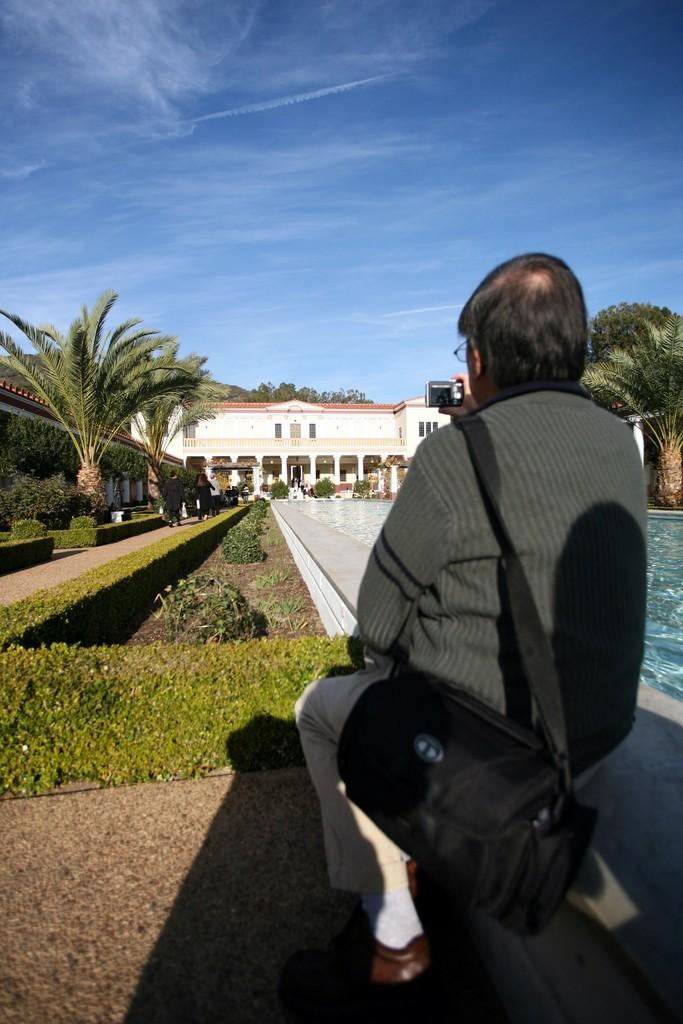What is the person in the image doing? The person is taking a photo. What can be seen behind the person in the image? There are trees, plants, water, a building, and the sky visible behind the person. Can you describe the natural environment in the image? The natural environment includes trees, plants, and water. What type of structure is visible behind the person? There is a building visible behind the person. What type of sound can be heard coming from the frame in the image? There is no frame present in the image, and therefore no sound can be heard coming from it. 